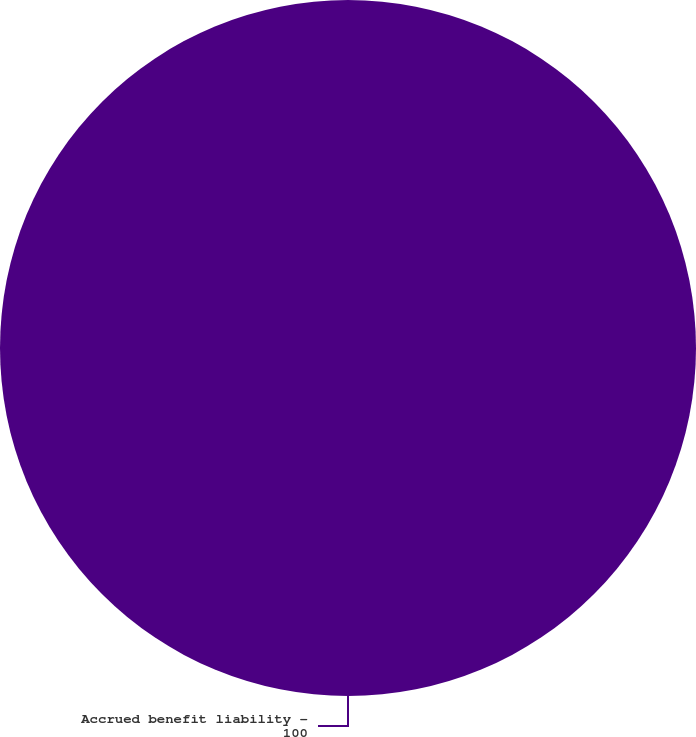Convert chart to OTSL. <chart><loc_0><loc_0><loc_500><loc_500><pie_chart><fcel>Accrued benefit liability -<nl><fcel>100.0%<nl></chart> 